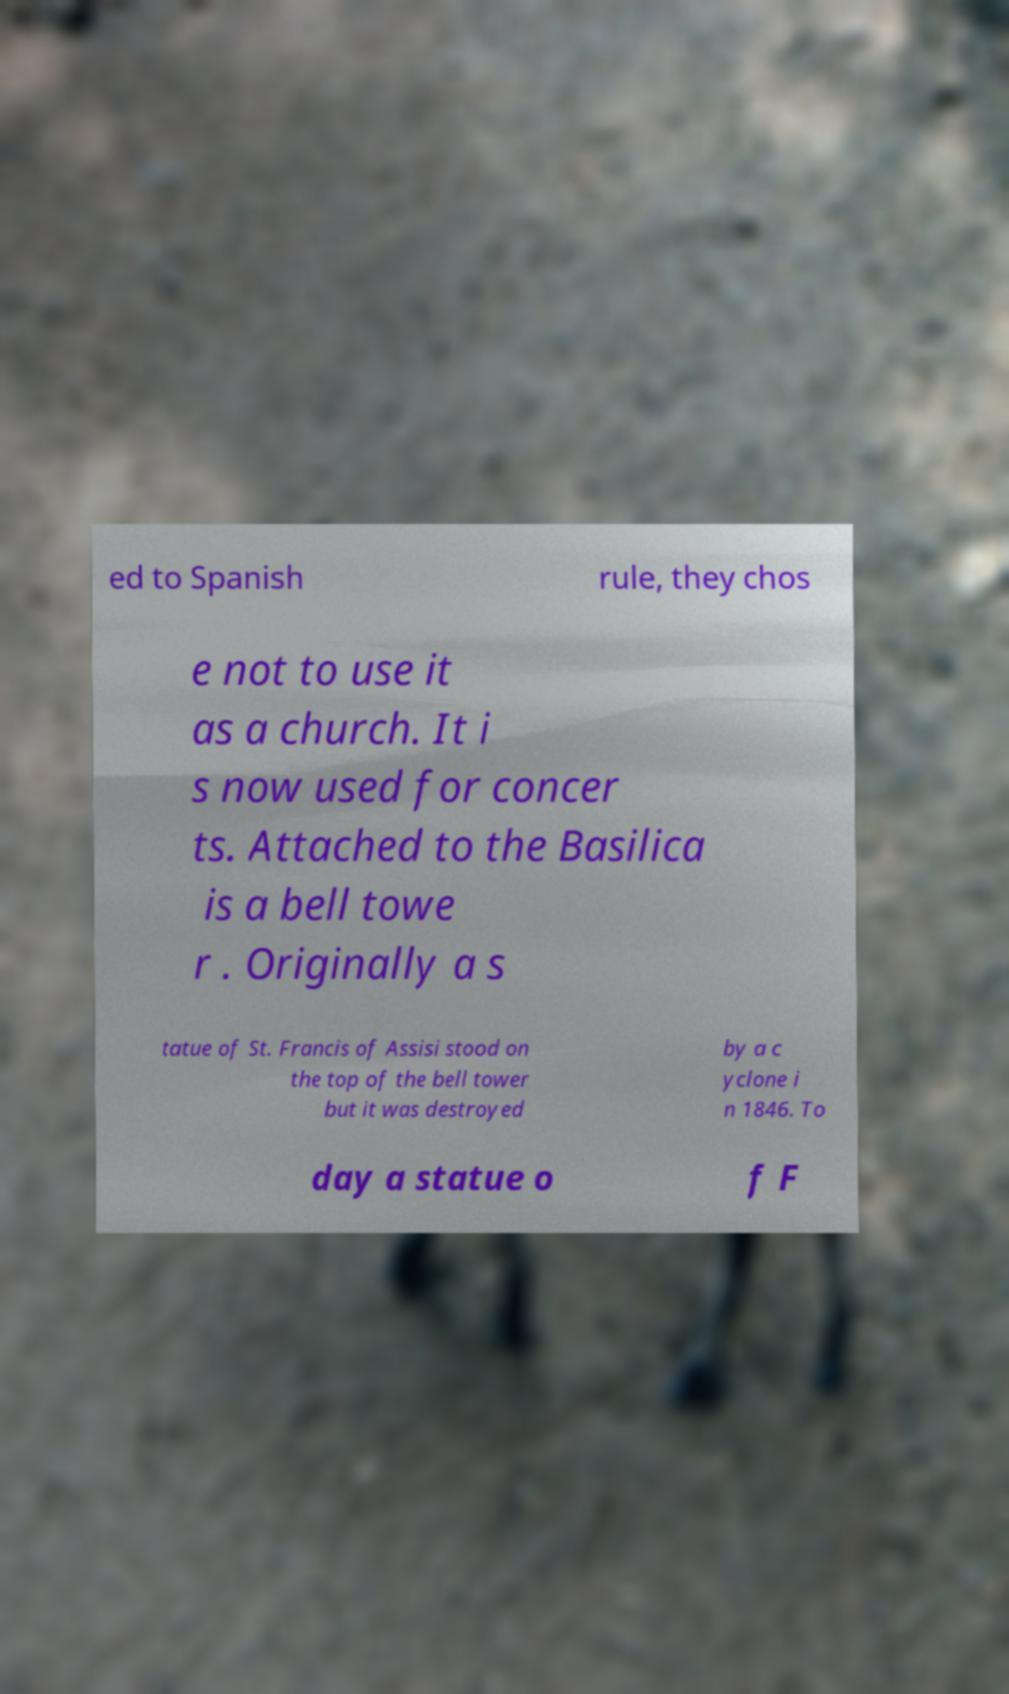What messages or text are displayed in this image? I need them in a readable, typed format. ed to Spanish rule, they chos e not to use it as a church. It i s now used for concer ts. Attached to the Basilica is a bell towe r . Originally a s tatue of St. Francis of Assisi stood on the top of the bell tower but it was destroyed by a c yclone i n 1846. To day a statue o f F 